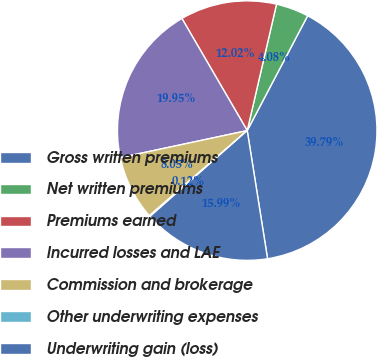<chart> <loc_0><loc_0><loc_500><loc_500><pie_chart><fcel>Gross written premiums<fcel>Net written premiums<fcel>Premiums earned<fcel>Incurred losses and LAE<fcel>Commission and brokerage<fcel>Other underwriting expenses<fcel>Underwriting gain (loss)<nl><fcel>39.79%<fcel>4.08%<fcel>12.02%<fcel>19.95%<fcel>8.05%<fcel>0.12%<fcel>15.99%<nl></chart> 